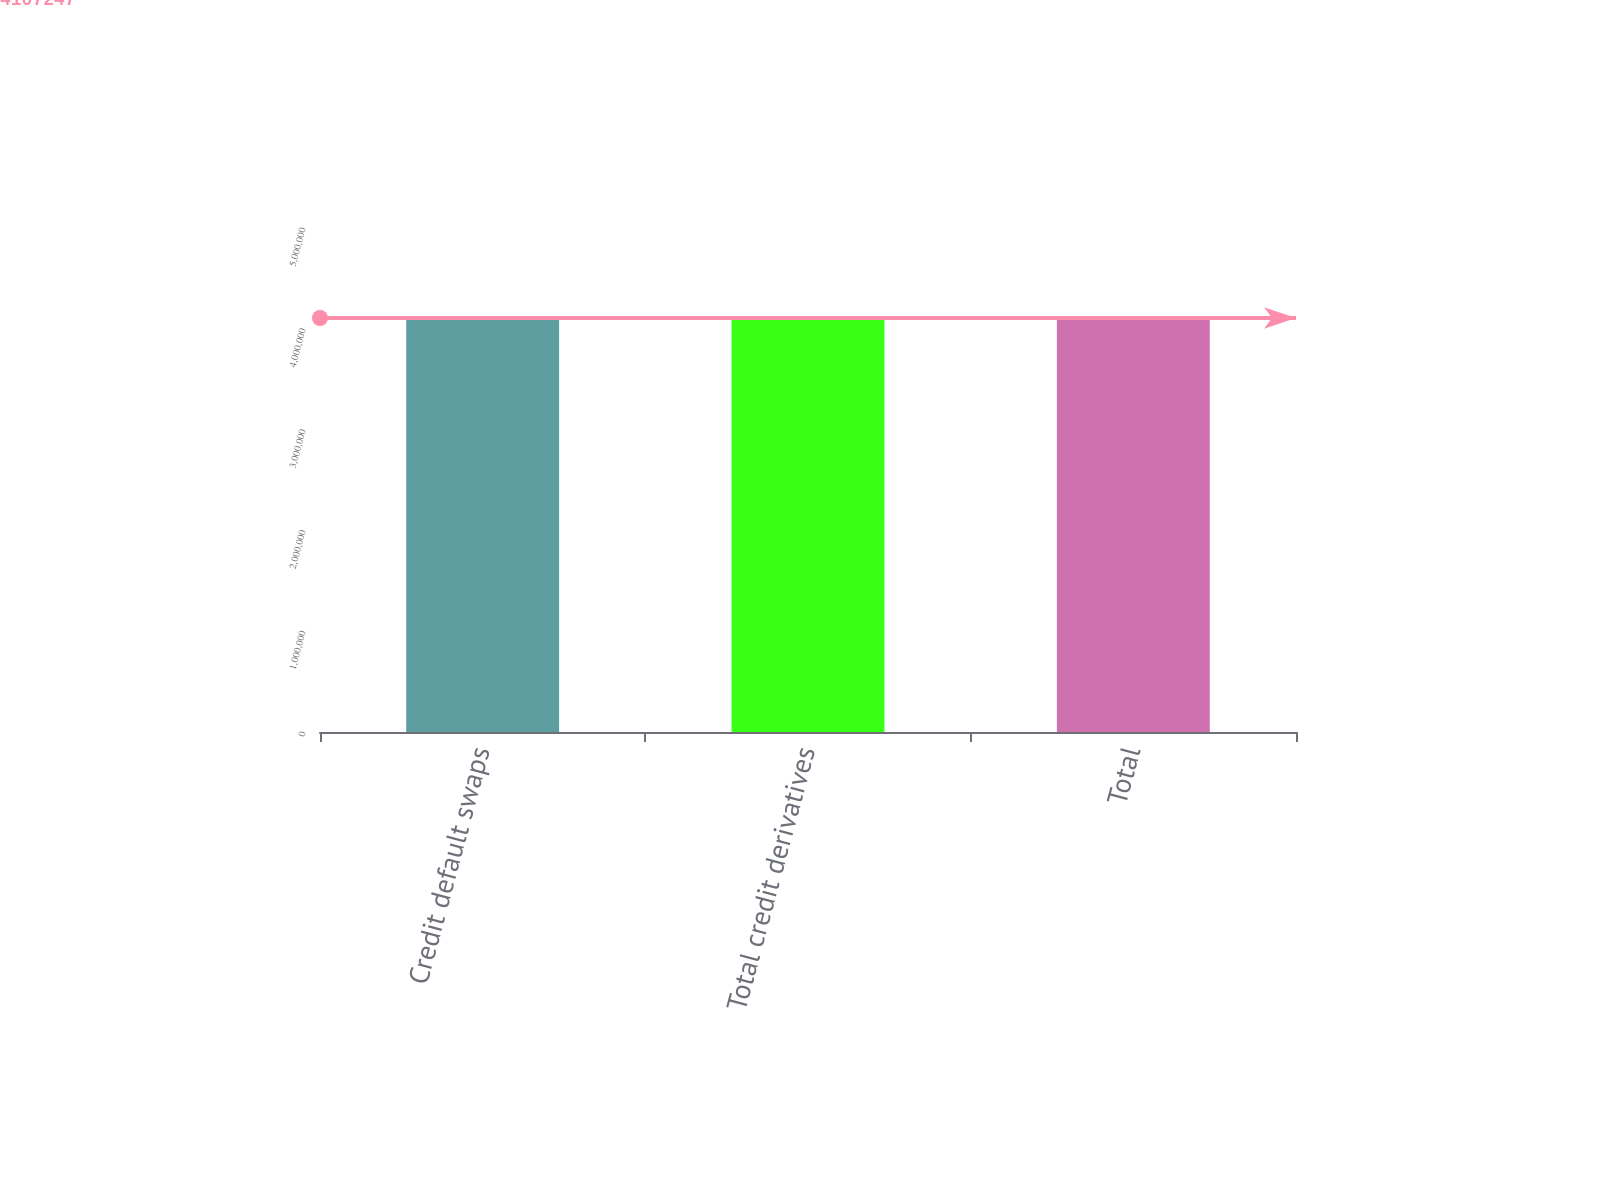Convert chart to OTSL. <chart><loc_0><loc_0><loc_500><loc_500><bar_chart><fcel>Credit default swaps<fcel>Total credit derivatives<fcel>Total<nl><fcel>4.09914e+06<fcel>4.10317e+06<fcel>4.10725e+06<nl></chart> 